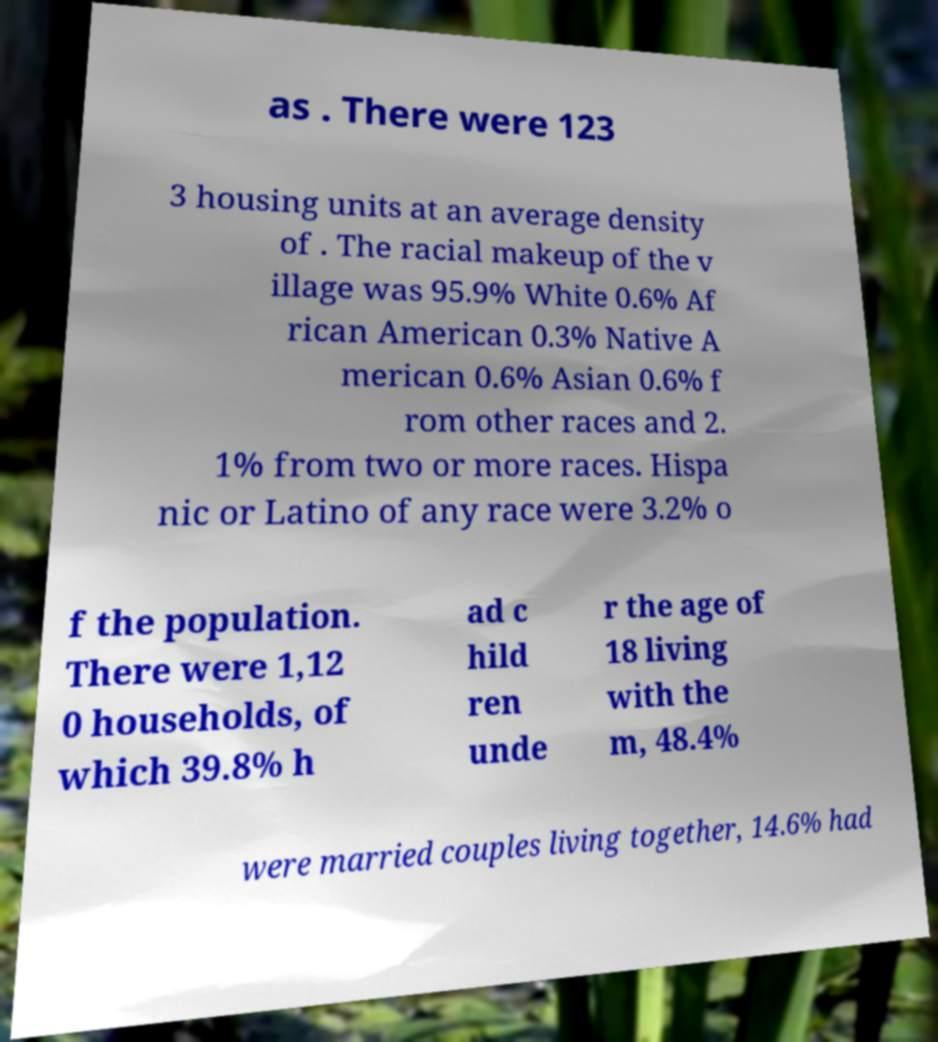Could you assist in decoding the text presented in this image and type it out clearly? as . There were 123 3 housing units at an average density of . The racial makeup of the v illage was 95.9% White 0.6% Af rican American 0.3% Native A merican 0.6% Asian 0.6% f rom other races and 2. 1% from two or more races. Hispa nic or Latino of any race were 3.2% o f the population. There were 1,12 0 households, of which 39.8% h ad c hild ren unde r the age of 18 living with the m, 48.4% were married couples living together, 14.6% had 